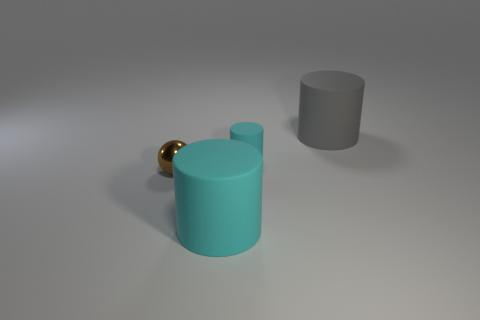Is there any other thing that is the same shape as the tiny metallic object?
Provide a succinct answer. No. There is a gray matte cylinder on the right side of the big cylinder that is in front of the gray rubber object; what size is it?
Make the answer very short. Large. The big gray matte object is what shape?
Provide a succinct answer. Cylinder. What number of tiny objects are red metal things or gray cylinders?
Ensure brevity in your answer.  0. There is another cyan matte thing that is the same shape as the big cyan matte object; what size is it?
Your response must be concise. Small. How many things are both left of the big gray matte thing and on the right side of the brown thing?
Your response must be concise. 2. There is a gray rubber object; is its shape the same as the big object that is on the left side of the gray matte thing?
Make the answer very short. Yes. Is the number of large cyan rubber cylinders behind the small matte cylinder greater than the number of tiny brown metal objects?
Your answer should be compact. No. Are there fewer brown objects right of the small brown object than large blue metallic blocks?
Give a very brief answer. No. What number of rubber objects are the same color as the tiny rubber cylinder?
Give a very brief answer. 1. 